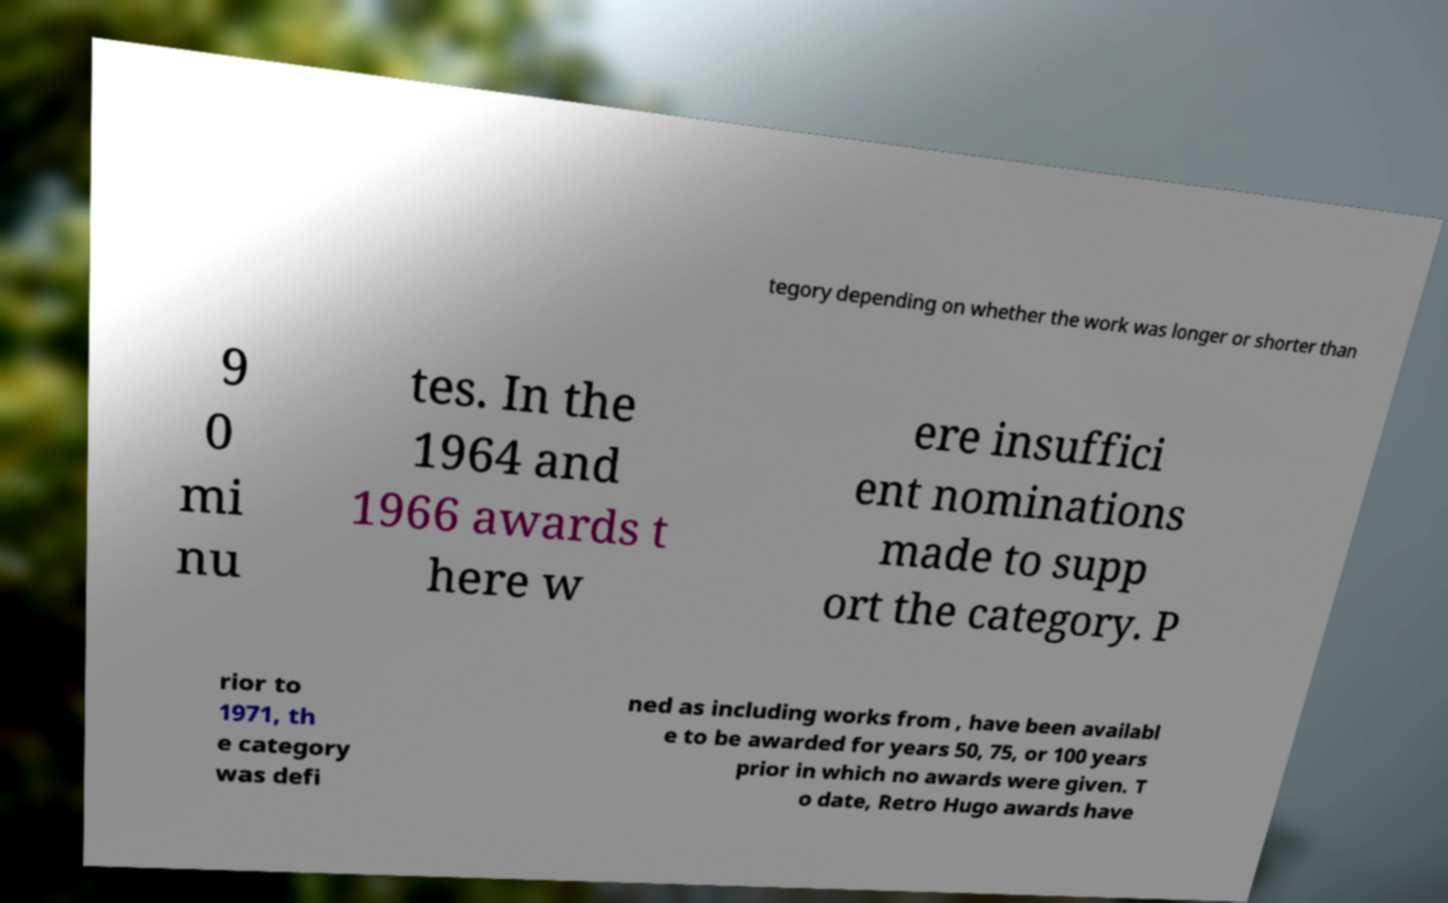Can you accurately transcribe the text from the provided image for me? tegory depending on whether the work was longer or shorter than 9 0 mi nu tes. In the 1964 and 1966 awards t here w ere insuffici ent nominations made to supp ort the category. P rior to 1971, th e category was defi ned as including works from , have been availabl e to be awarded for years 50, 75, or 100 years prior in which no awards were given. T o date, Retro Hugo awards have 